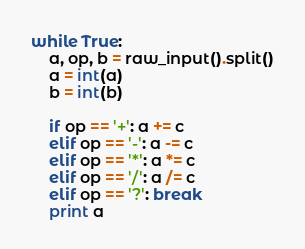Convert code to text. <code><loc_0><loc_0><loc_500><loc_500><_Python_>while True:
    a, op, b = raw_input().split()
    a = int(a)
    b = int(b)

    if op == '+': a += c
    elif op == '-': a -= c
    elif op == '*': a *= c 
    elif op == '/': a /= c
    elif op == '?': break
    print a</code> 